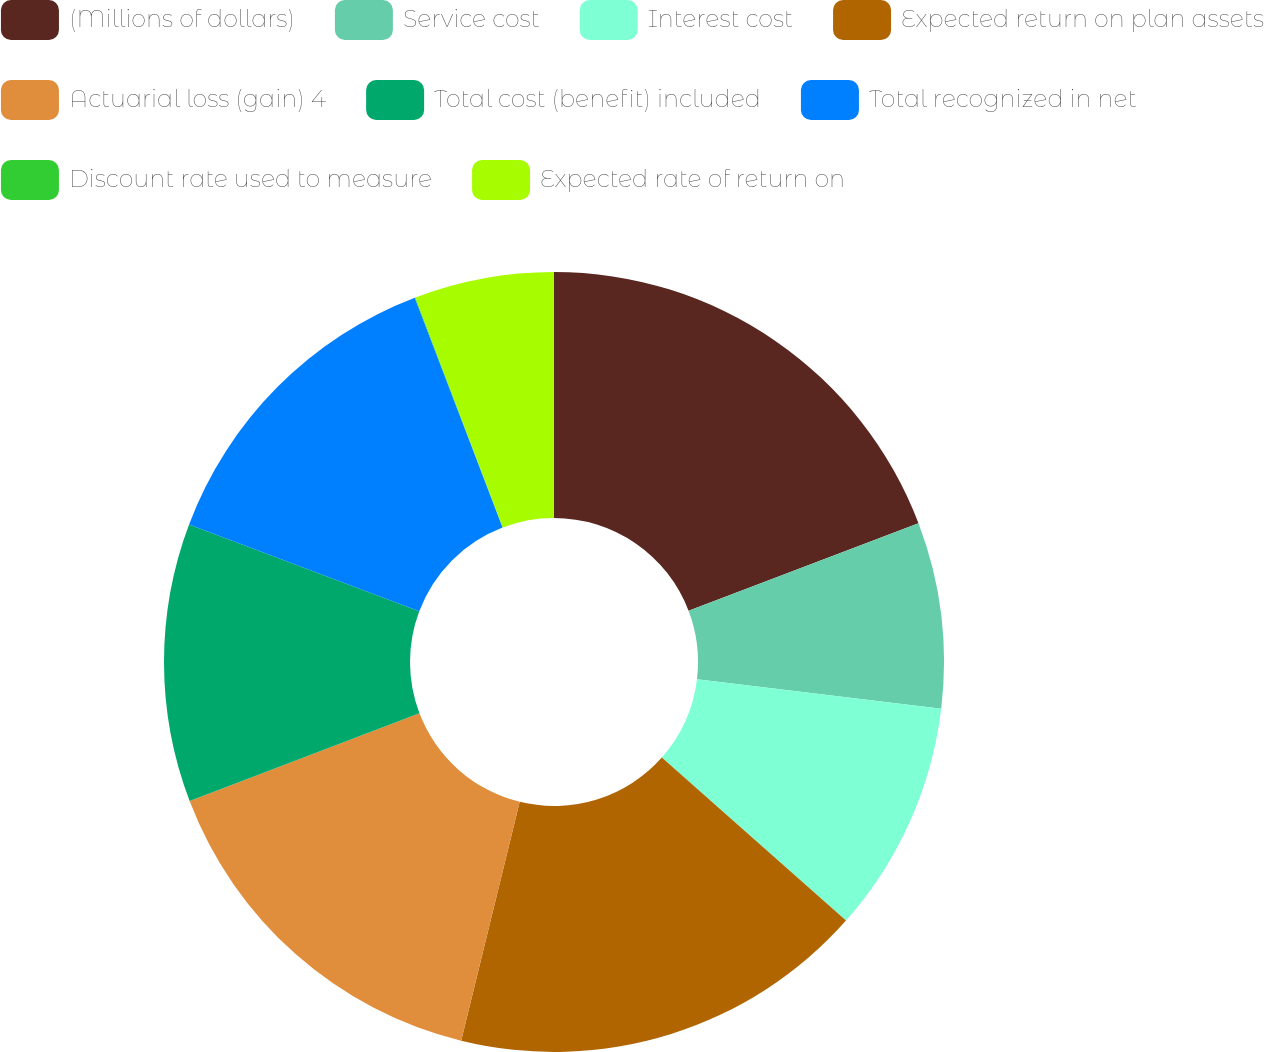Convert chart. <chart><loc_0><loc_0><loc_500><loc_500><pie_chart><fcel>(Millions of dollars)<fcel>Service cost<fcel>Interest cost<fcel>Expected return on plan assets<fcel>Actuarial loss (gain) 4<fcel>Total cost (benefit) included<fcel>Total recognized in net<fcel>Discount rate used to measure<fcel>Expected rate of return on<nl><fcel>19.21%<fcel>7.7%<fcel>9.62%<fcel>17.29%<fcel>15.37%<fcel>11.54%<fcel>13.45%<fcel>0.03%<fcel>5.78%<nl></chart> 